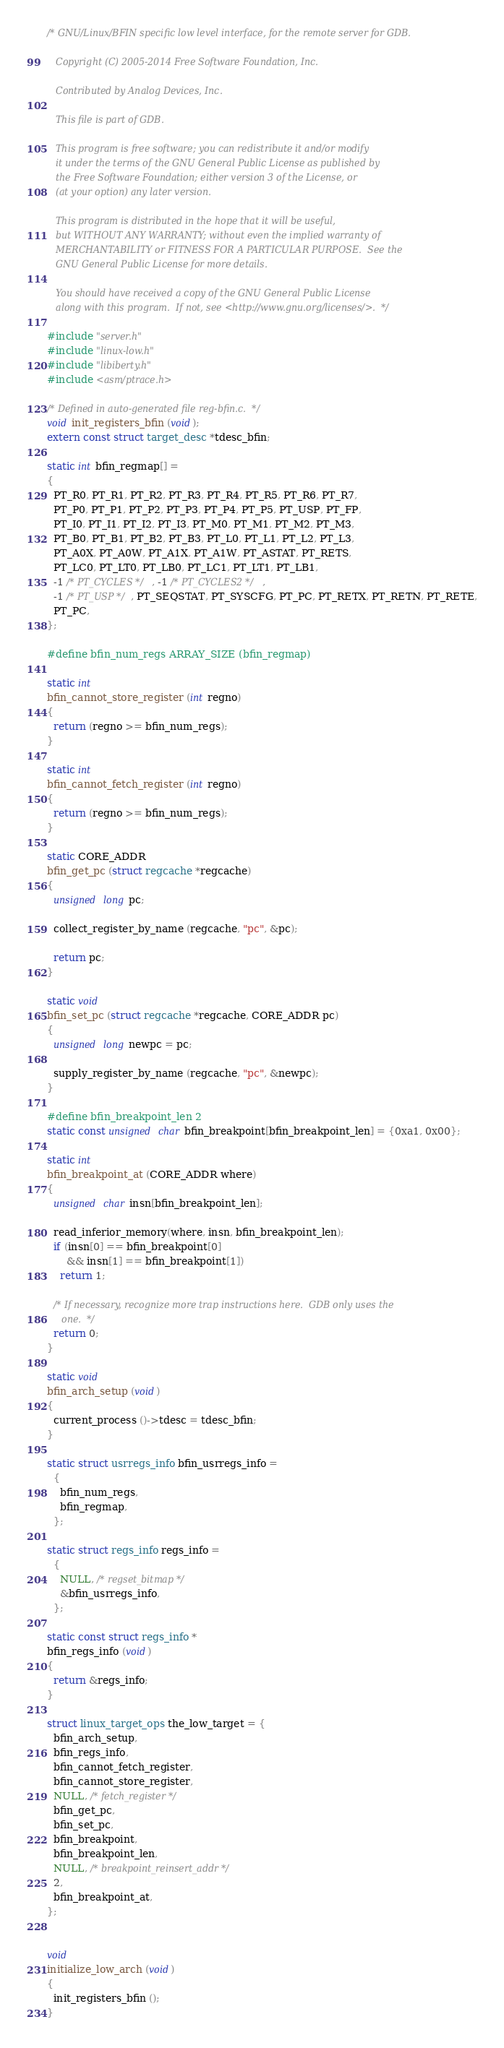Convert code to text. <code><loc_0><loc_0><loc_500><loc_500><_C_>/* GNU/Linux/BFIN specific low level interface, for the remote server for GDB.

   Copyright (C) 2005-2014 Free Software Foundation, Inc.

   Contributed by Analog Devices, Inc.

   This file is part of GDB.

   This program is free software; you can redistribute it and/or modify
   it under the terms of the GNU General Public License as published by
   the Free Software Foundation; either version 3 of the License, or
   (at your option) any later version.

   This program is distributed in the hope that it will be useful,
   but WITHOUT ANY WARRANTY; without even the implied warranty of
   MERCHANTABILITY or FITNESS FOR A PARTICULAR PURPOSE.  See the
   GNU General Public License for more details.

   You should have received a copy of the GNU General Public License
   along with this program.  If not, see <http://www.gnu.org/licenses/>.  */

#include "server.h"
#include "linux-low.h"
#include "libiberty.h"
#include <asm/ptrace.h>

/* Defined in auto-generated file reg-bfin.c.  */
void init_registers_bfin (void);
extern const struct target_desc *tdesc_bfin;

static int bfin_regmap[] =
{
  PT_R0, PT_R1, PT_R2, PT_R3, PT_R4, PT_R5, PT_R6, PT_R7,
  PT_P0, PT_P1, PT_P2, PT_P3, PT_P4, PT_P5, PT_USP, PT_FP,
  PT_I0, PT_I1, PT_I2, PT_I3, PT_M0, PT_M1, PT_M2, PT_M3,
  PT_B0, PT_B1, PT_B2, PT_B3, PT_L0, PT_L1, PT_L2, PT_L3,
  PT_A0X, PT_A0W, PT_A1X, PT_A1W, PT_ASTAT, PT_RETS,
  PT_LC0, PT_LT0, PT_LB0, PT_LC1, PT_LT1, PT_LB1,
  -1 /* PT_CYCLES */, -1 /* PT_CYCLES2 */,
  -1 /* PT_USP */, PT_SEQSTAT, PT_SYSCFG, PT_PC, PT_RETX, PT_RETN, PT_RETE,
  PT_PC,
};

#define bfin_num_regs ARRAY_SIZE (bfin_regmap)

static int
bfin_cannot_store_register (int regno)
{
  return (regno >= bfin_num_regs);
}

static int
bfin_cannot_fetch_register (int regno)
{
  return (regno >= bfin_num_regs);
}

static CORE_ADDR
bfin_get_pc (struct regcache *regcache)
{
  unsigned long pc;

  collect_register_by_name (regcache, "pc", &pc);

  return pc;
}

static void
bfin_set_pc (struct regcache *regcache, CORE_ADDR pc)
{
  unsigned long newpc = pc;

  supply_register_by_name (regcache, "pc", &newpc);
}

#define bfin_breakpoint_len 2
static const unsigned char bfin_breakpoint[bfin_breakpoint_len] = {0xa1, 0x00};

static int
bfin_breakpoint_at (CORE_ADDR where)
{
  unsigned char insn[bfin_breakpoint_len];

  read_inferior_memory(where, insn, bfin_breakpoint_len);
  if (insn[0] == bfin_breakpoint[0]
      && insn[1] == bfin_breakpoint[1])
    return 1;

  /* If necessary, recognize more trap instructions here.  GDB only uses the
     one.  */
  return 0;
}

static void
bfin_arch_setup (void)
{
  current_process ()->tdesc = tdesc_bfin;
}

static struct usrregs_info bfin_usrregs_info =
  {
    bfin_num_regs,
    bfin_regmap,
  };

static struct regs_info regs_info =
  {
    NULL, /* regset_bitmap */
    &bfin_usrregs_info,
  };

static const struct regs_info *
bfin_regs_info (void)
{
  return &regs_info;
}

struct linux_target_ops the_low_target = {
  bfin_arch_setup,
  bfin_regs_info,
  bfin_cannot_fetch_register,
  bfin_cannot_store_register,
  NULL, /* fetch_register */
  bfin_get_pc,
  bfin_set_pc,
  bfin_breakpoint,
  bfin_breakpoint_len,
  NULL, /* breakpoint_reinsert_addr */
  2,
  bfin_breakpoint_at,
};


void
initialize_low_arch (void)
{
  init_registers_bfin ();
}
</code> 